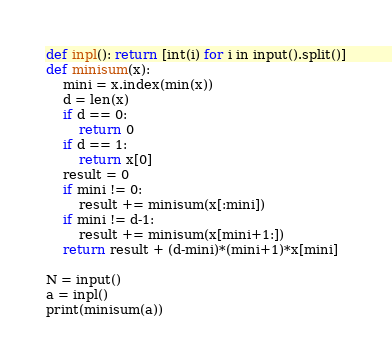Convert code to text. <code><loc_0><loc_0><loc_500><loc_500><_Python_>def inpl(): return [int(i) for i in input().split()]
def minisum(x):
    mini = x.index(min(x))
    d = len(x)
    if d == 0:
        return 0
    if d == 1:
        return x[0]
    result = 0
    if mini != 0:
        result += minisum(x[:mini])
    if mini != d-1:
        result += minisum(x[mini+1:])
    return result + (d-mini)*(mini+1)*x[mini]

N = input()
a = inpl()
print(minisum(a))</code> 